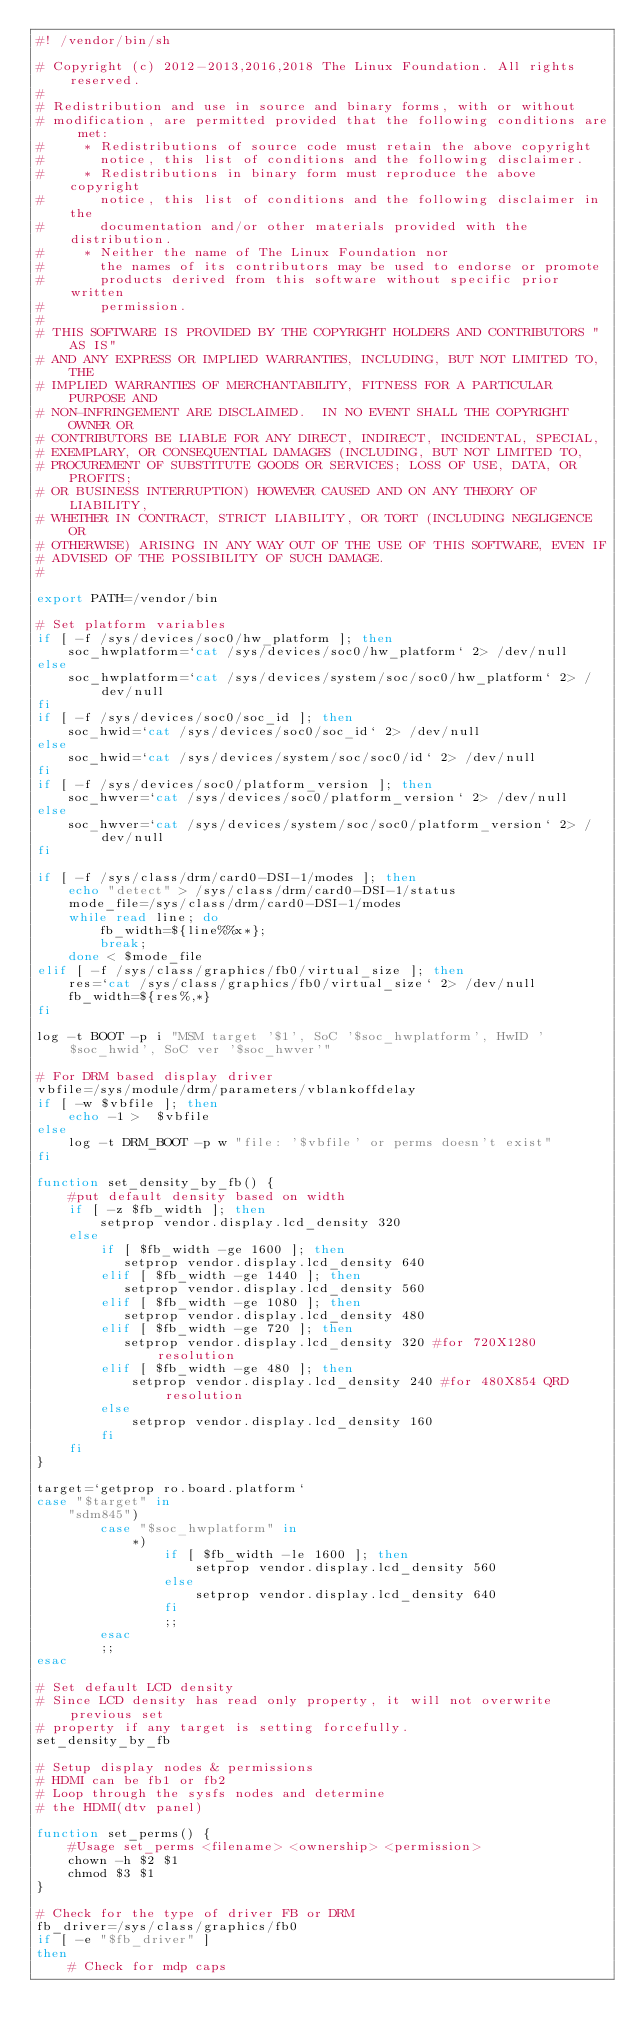Convert code to text. <code><loc_0><loc_0><loc_500><loc_500><_Bash_>#! /vendor/bin/sh

# Copyright (c) 2012-2013,2016,2018 The Linux Foundation. All rights reserved.
#
# Redistribution and use in source and binary forms, with or without
# modification, are permitted provided that the following conditions are met:
#     * Redistributions of source code must retain the above copyright
#       notice, this list of conditions and the following disclaimer.
#     * Redistributions in binary form must reproduce the above copyright
#       notice, this list of conditions and the following disclaimer in the
#       documentation and/or other materials provided with the distribution.
#     * Neither the name of The Linux Foundation nor
#       the names of its contributors may be used to endorse or promote
#       products derived from this software without specific prior written
#       permission.
#
# THIS SOFTWARE IS PROVIDED BY THE COPYRIGHT HOLDERS AND CONTRIBUTORS "AS IS"
# AND ANY EXPRESS OR IMPLIED WARRANTIES, INCLUDING, BUT NOT LIMITED TO, THE
# IMPLIED WARRANTIES OF MERCHANTABILITY, FITNESS FOR A PARTICULAR PURPOSE AND
# NON-INFRINGEMENT ARE DISCLAIMED.  IN NO EVENT SHALL THE COPYRIGHT OWNER OR
# CONTRIBUTORS BE LIABLE FOR ANY DIRECT, INDIRECT, INCIDENTAL, SPECIAL,
# EXEMPLARY, OR CONSEQUENTIAL DAMAGES (INCLUDING, BUT NOT LIMITED TO,
# PROCUREMENT OF SUBSTITUTE GOODS OR SERVICES; LOSS OF USE, DATA, OR PROFITS;
# OR BUSINESS INTERRUPTION) HOWEVER CAUSED AND ON ANY THEORY OF LIABILITY,
# WHETHER IN CONTRACT, STRICT LIABILITY, OR TORT (INCLUDING NEGLIGENCE OR
# OTHERWISE) ARISING IN ANY WAY OUT OF THE USE OF THIS SOFTWARE, EVEN IF
# ADVISED OF THE POSSIBILITY OF SUCH DAMAGE.
#

export PATH=/vendor/bin

# Set platform variables
if [ -f /sys/devices/soc0/hw_platform ]; then
    soc_hwplatform=`cat /sys/devices/soc0/hw_platform` 2> /dev/null
else
    soc_hwplatform=`cat /sys/devices/system/soc/soc0/hw_platform` 2> /dev/null
fi
if [ -f /sys/devices/soc0/soc_id ]; then
    soc_hwid=`cat /sys/devices/soc0/soc_id` 2> /dev/null
else
    soc_hwid=`cat /sys/devices/system/soc/soc0/id` 2> /dev/null
fi
if [ -f /sys/devices/soc0/platform_version ]; then
    soc_hwver=`cat /sys/devices/soc0/platform_version` 2> /dev/null
else
    soc_hwver=`cat /sys/devices/system/soc/soc0/platform_version` 2> /dev/null
fi

if [ -f /sys/class/drm/card0-DSI-1/modes ]; then
    echo "detect" > /sys/class/drm/card0-DSI-1/status
    mode_file=/sys/class/drm/card0-DSI-1/modes
    while read line; do
        fb_width=${line%%x*};
        break;
    done < $mode_file
elif [ -f /sys/class/graphics/fb0/virtual_size ]; then
    res=`cat /sys/class/graphics/fb0/virtual_size` 2> /dev/null
    fb_width=${res%,*}
fi

log -t BOOT -p i "MSM target '$1', SoC '$soc_hwplatform', HwID '$soc_hwid', SoC ver '$soc_hwver'"

# For DRM based display driver
vbfile=/sys/module/drm/parameters/vblankoffdelay
if [ -w $vbfile ]; then
    echo -1 >  $vbfile
else
    log -t DRM_BOOT -p w "file: '$vbfile' or perms doesn't exist"
fi

function set_density_by_fb() {
    #put default density based on width
    if [ -z $fb_width ]; then
        setprop vendor.display.lcd_density 320
    else
        if [ $fb_width -ge 1600 ]; then
           setprop vendor.display.lcd_density 640
        elif [ $fb_width -ge 1440 ]; then
           setprop vendor.display.lcd_density 560
        elif [ $fb_width -ge 1080 ]; then
           setprop vendor.display.lcd_density 480
        elif [ $fb_width -ge 720 ]; then
           setprop vendor.display.lcd_density 320 #for 720X1280 resolution
        elif [ $fb_width -ge 480 ]; then
            setprop vendor.display.lcd_density 240 #for 480X854 QRD resolution
        else
            setprop vendor.display.lcd_density 160
        fi
    fi
}

target=`getprop ro.board.platform`
case "$target" in
    "sdm845")
        case "$soc_hwplatform" in
            *)
                if [ $fb_width -le 1600 ]; then
                    setprop vendor.display.lcd_density 560
                else
                    setprop vendor.display.lcd_density 640
                fi
                ;;
        esac
        ;;
esac

# Set default LCD density
# Since LCD density has read only property, it will not overwrite previous set
# property if any target is setting forcefully.
set_density_by_fb

# Setup display nodes & permissions
# HDMI can be fb1 or fb2
# Loop through the sysfs nodes and determine
# the HDMI(dtv panel)

function set_perms() {
    #Usage set_perms <filename> <ownership> <permission>
    chown -h $2 $1
    chmod $3 $1
}

# Check for the type of driver FB or DRM
fb_driver=/sys/class/graphics/fb0
if [ -e "$fb_driver" ]
then
    # Check for mdp caps</code> 